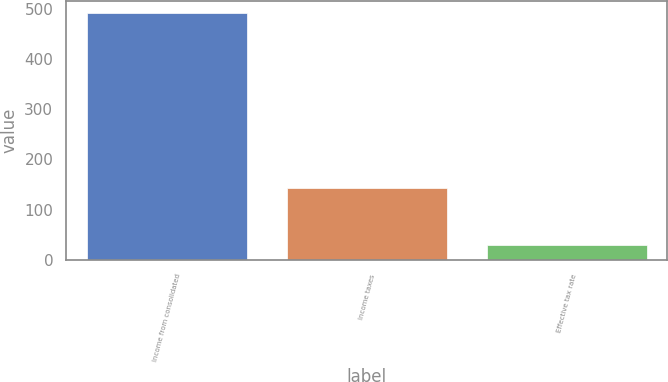Convert chart to OTSL. <chart><loc_0><loc_0><loc_500><loc_500><bar_chart><fcel>Income from consolidated<fcel>Income taxes<fcel>Effective tax rate<nl><fcel>491.4<fcel>142.6<fcel>29<nl></chart> 